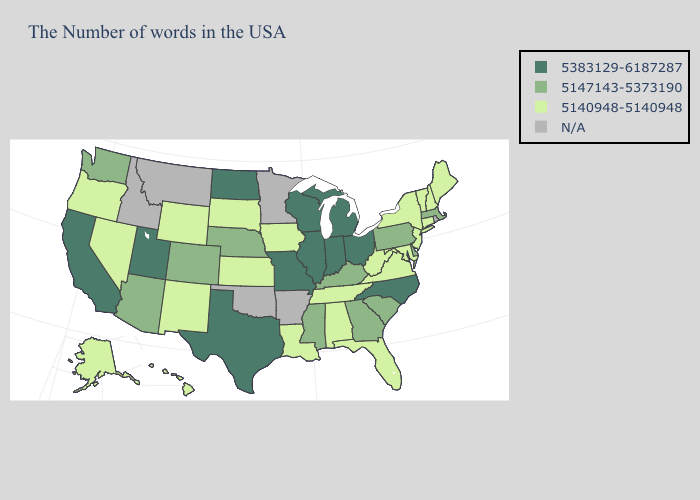Name the states that have a value in the range 5147143-5373190?
Be succinct. Massachusetts, Delaware, Pennsylvania, South Carolina, Georgia, Kentucky, Mississippi, Nebraska, Colorado, Arizona, Washington. Name the states that have a value in the range N/A?
Write a very short answer. Rhode Island, Arkansas, Minnesota, Oklahoma, Montana, Idaho. Name the states that have a value in the range N/A?
Concise answer only. Rhode Island, Arkansas, Minnesota, Oklahoma, Montana, Idaho. What is the highest value in states that border Michigan?
Quick response, please. 5383129-6187287. Name the states that have a value in the range N/A?
Give a very brief answer. Rhode Island, Arkansas, Minnesota, Oklahoma, Montana, Idaho. Among the states that border Florida , does Georgia have the lowest value?
Answer briefly. No. Does the map have missing data?
Concise answer only. Yes. Name the states that have a value in the range 5147143-5373190?
Quick response, please. Massachusetts, Delaware, Pennsylvania, South Carolina, Georgia, Kentucky, Mississippi, Nebraska, Colorado, Arizona, Washington. How many symbols are there in the legend?
Quick response, please. 4. Name the states that have a value in the range 5147143-5373190?
Concise answer only. Massachusetts, Delaware, Pennsylvania, South Carolina, Georgia, Kentucky, Mississippi, Nebraska, Colorado, Arizona, Washington. Does Pennsylvania have the highest value in the Northeast?
Keep it brief. Yes. Does Hawaii have the highest value in the USA?
Short answer required. No. What is the value of New Hampshire?
Write a very short answer. 5140948-5140948. Does North Carolina have the highest value in the USA?
Answer briefly. Yes. 